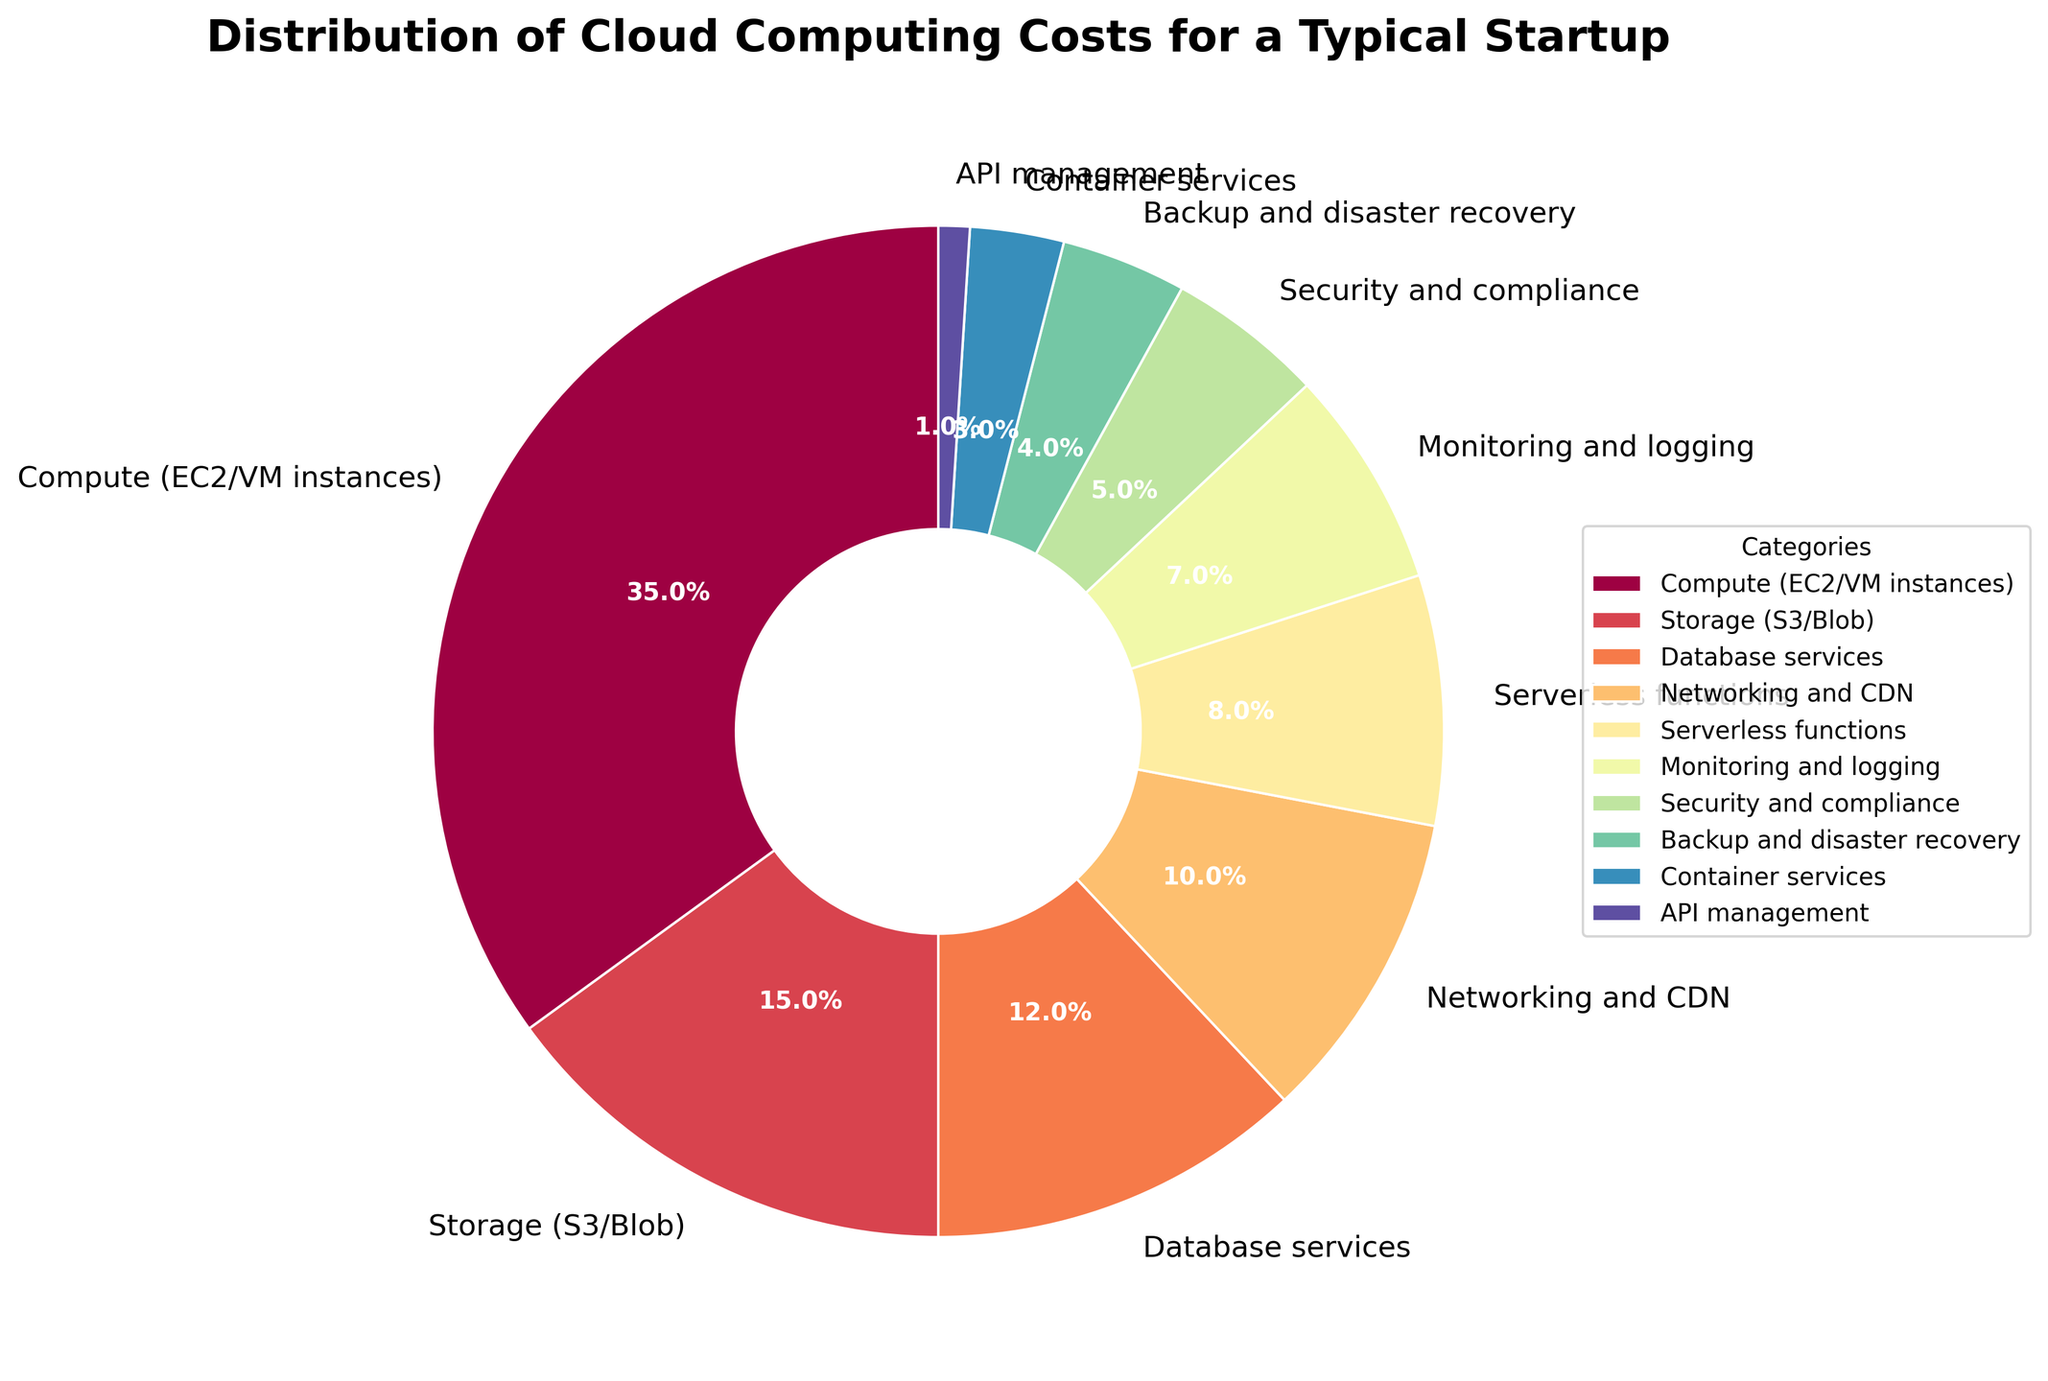Which category has the highest percentage of cloud computing costs? The pie chart shows that "Compute (EC2/VM instances)" occupies the largest section.
Answer: Compute (EC2/VM instances) What is the combined percentage of costs for Compute, Storage, and Database services? Sum the percentages for "Compute (EC2/VM instances)" (35%), "Storage (S3/Blob)" (15%), and "Database services" (12%). 35 + 15 + 12 = 62.
Answer: 62% How do the costs for Networking and CDN compare to those for Serverless functions? Compare the percentages. "Networking and CDN" is 10%, and "Serverless functions" is 8%. 10 is greater than 8.
Answer: Networking and CDN costs are higher What percentage of costs is associated with Monitoring and logging compared to Security and compliance? The pie chart shows that Monitoring and logging has 7% while Security and compliance has 5%. 7 is greater than 5.
Answer: Monitoring and logging costs are higher If we combined the costs of all categories except Compute, what would be the total percentage? Sum all categories except "Compute (EC2/VM instances)" (35%). 100 - 35 = 65.
Answer: 65% Which category has the smallest percentage of costs? The smallest section in the pie chart is "API management" with 1%.
Answer: API management Are the costs for Backup and disaster recovery higher or lower than those for Container services? Compare the sections for each category. Backup and disaster recovery is 4% and Container services is 3%. 4 is greater than 3.
Answer: Higher What is the total percentage for categories below 10% each? Add up the percentages for categories below 10%: Serverless functions (8%) + Monitoring and logging (7%) + Security and compliance (5%) + Backup and disaster recovery (4%) + Container services (3%) + API management (1%). 8 + 7 + 5 + 4 + 3 + 1 = 28.
Answer: 28% Which categories together make up one-third of the total costs? Identify categories whose combined percentages total approximately 33%. Storage (15%) + Database services (12%) + Monitoring and logging (7%) = 34%, which is close to one-third but slightly over. Instead use Storage + Database services + API management (1%). 15 + 12 + 1 = 28%, still not exact but closest.
Answer: Storage, Database services, API management What are the costs for categories that are visually more than half the size of the section for Serverless functions? Serverless functions is 8%, so half is 4%. Look for categories above 4%: Compute (35%), Storage (15%), Database services (12%), Networking and CDN (10%), Monitoring and logging (7%), Security and compliance (5%). Excludes Backup and disaster recovery (4%).
Answer: Compute, Storage, Database services, Networking and CDN, Monitoring and logging, Security and compliance 